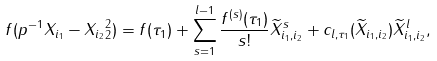Convert formula to latex. <formula><loc_0><loc_0><loc_500><loc_500>f ( p ^ { - 1 } \| X _ { i _ { 1 } } - X _ { i _ { 2 } } \| _ { 2 } ^ { 2 } ) = f ( \tau _ { 1 } ) + \sum ^ { l - 1 } _ { s = 1 } \frac { f ^ { ( s ) } ( \tau _ { 1 } ) } { s ! } \widetilde { X } _ { i _ { 1 } , i _ { 2 } } ^ { s } + c _ { l , \tau _ { 1 } } ( \widetilde { X } _ { i _ { 1 } , i _ { 2 } } ) \widetilde { X } _ { i _ { 1 } , i _ { 2 } } ^ { l } ,</formula> 